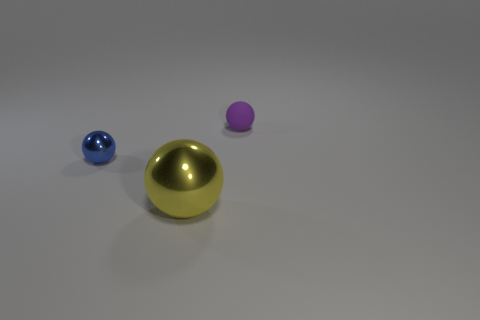Subtract 1 balls. How many balls are left? 2 Add 3 tiny metal balls. How many objects exist? 6 Add 3 tiny rubber spheres. How many tiny rubber spheres exist? 4 Subtract 0 cyan spheres. How many objects are left? 3 Subtract all big yellow metallic spheres. Subtract all purple matte things. How many objects are left? 1 Add 1 purple matte objects. How many purple matte objects are left? 2 